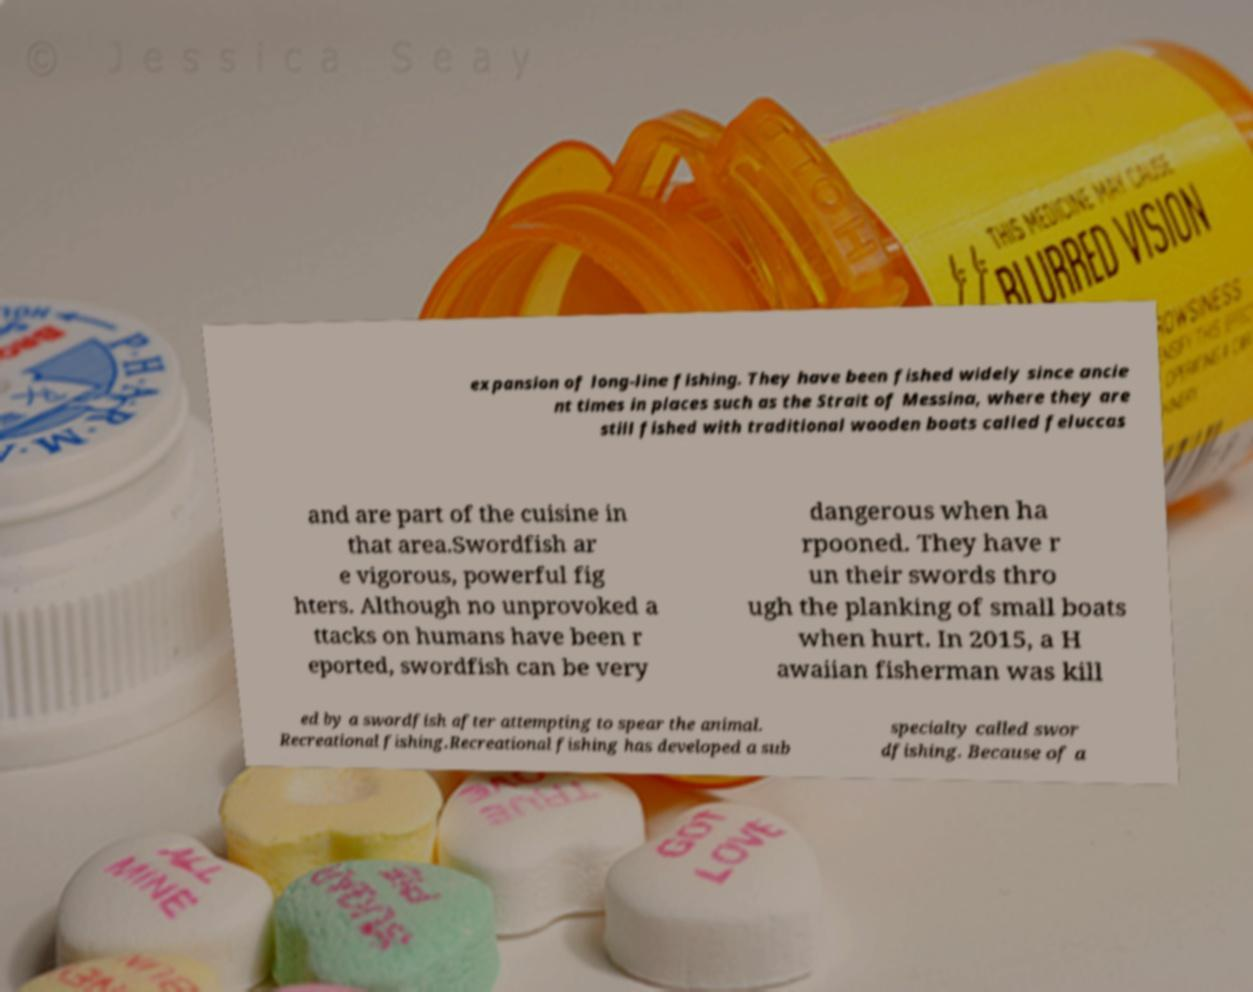Could you extract and type out the text from this image? expansion of long-line fishing. They have been fished widely since ancie nt times in places such as the Strait of Messina, where they are still fished with traditional wooden boats called feluccas and are part of the cuisine in that area.Swordfish ar e vigorous, powerful fig hters. Although no unprovoked a ttacks on humans have been r eported, swordfish can be very dangerous when ha rpooned. They have r un their swords thro ugh the planking of small boats when hurt. In 2015, a H awaiian fisherman was kill ed by a swordfish after attempting to spear the animal. Recreational fishing.Recreational fishing has developed a sub specialty called swor dfishing. Because of a 